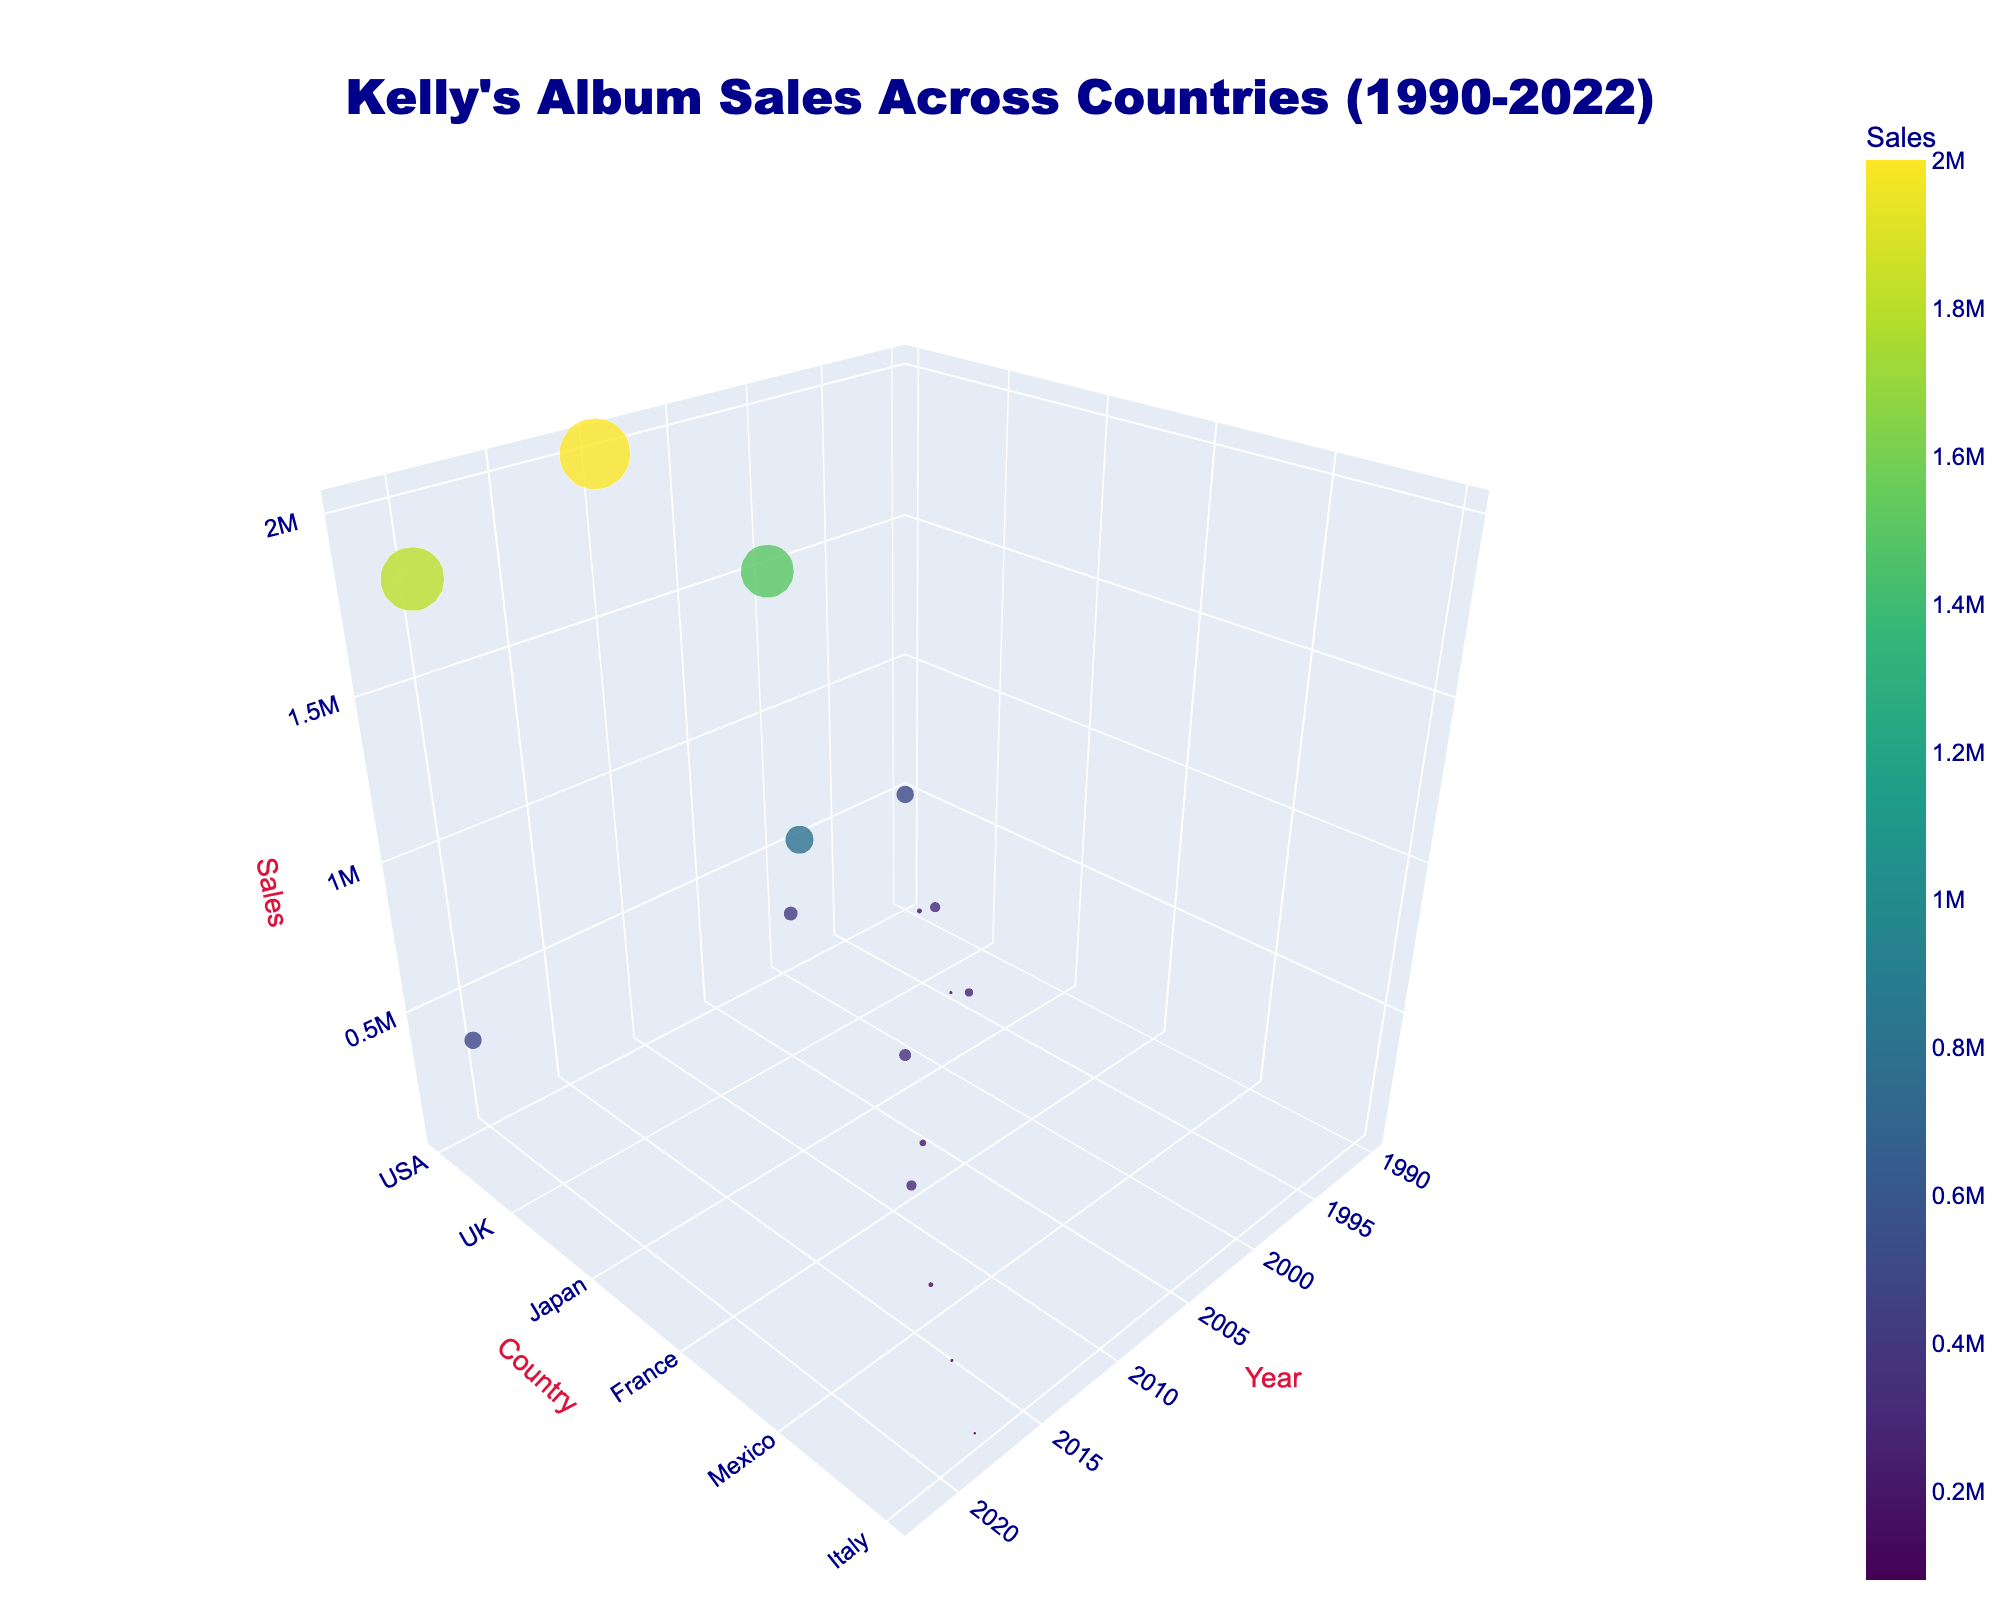What is the title of the figure? The title is located at the top center of the figure. Reading from the plot, the title states "Kelly's Album Sales Across Countries (1990-2022)."
Answer: Kelly's Album Sales Across Countries (1990-2022) Which country had the highest sales in 2000? The sales data points are marked as dots on the scatter plot with respective sizes and colors indicating the sales volume. Looking at the year 2000, the largest and highest sales point corresponds to the USA.
Answer: USA How many countries are represented in the scatter plot? To determine the number of unique countries, look at the y-axis which represents different countries. Counting all unique labels along this axis, there are 11 countries represented.
Answer: 11 What are the sales in Canada in 1992 and how do they compare to the sales in Canada in 2022? Identify the points for Canada for both 1992 and 2022 on the plot and compare their sales values. In 1992, sales in Canada were 150,000 while in 2022, they were 500,000. There is an increase of 350,000 sales when comparing these years.
Answer: 150,000 in 1992; 500,000 in 2022; increased by 350,000 Which year recorded the highest sales overall and in which country did it occur? Identify the highest point on the z-axis (sales) and correlate it with the x-axis (year) and y-axis (country) value. The year with the highest sales is 2010 in the USA.
Answer: 2010 in USA What is the average sales volume across all countries in 2012? To find the average, look at the data point for 2012 and consider the sales values. The only country represented in 2012 is Brazil with sales of 300,000. Since it is the only data point, the average is the same as the value.
Answer: 300,000 Which year did Kelly have her lowest recorded sales and in which country? By locating the smallest point on the z-axis (sales), the year with the lowest recorded sales is 2018 in Italy, with 80,000 sales.
Answer: 2018 in Italy How did Kelly's sales in the USA change from 1990 to 2020? Look at the data points for the USA in 1990 and 2020 and compare the sales. Sales increased from 500,000 in 1990 to 1,800,000 in 2020.
Answer: Increased from 500,000 to 1,800,000 From the data points, which continents show representation of Kelly's album sales? By observing the countries, which include USA, Canada, UK, Australia, Japan, Germany, France, Brazil, Mexico, Spain, and Italy, we can group them by continents. North America, Europe, Asia, and Australia are represented.
Answer: North America, Europe, Asia, Australia How many years after 1990 did Kelly's sales in Japan occur? Looking at the year axis for Japan's sales, it occurred in 1998. Subtracting 1990 from 1998, it took 8 years after 1990 for the sales data in Japan to appear.
Answer: 8 years 